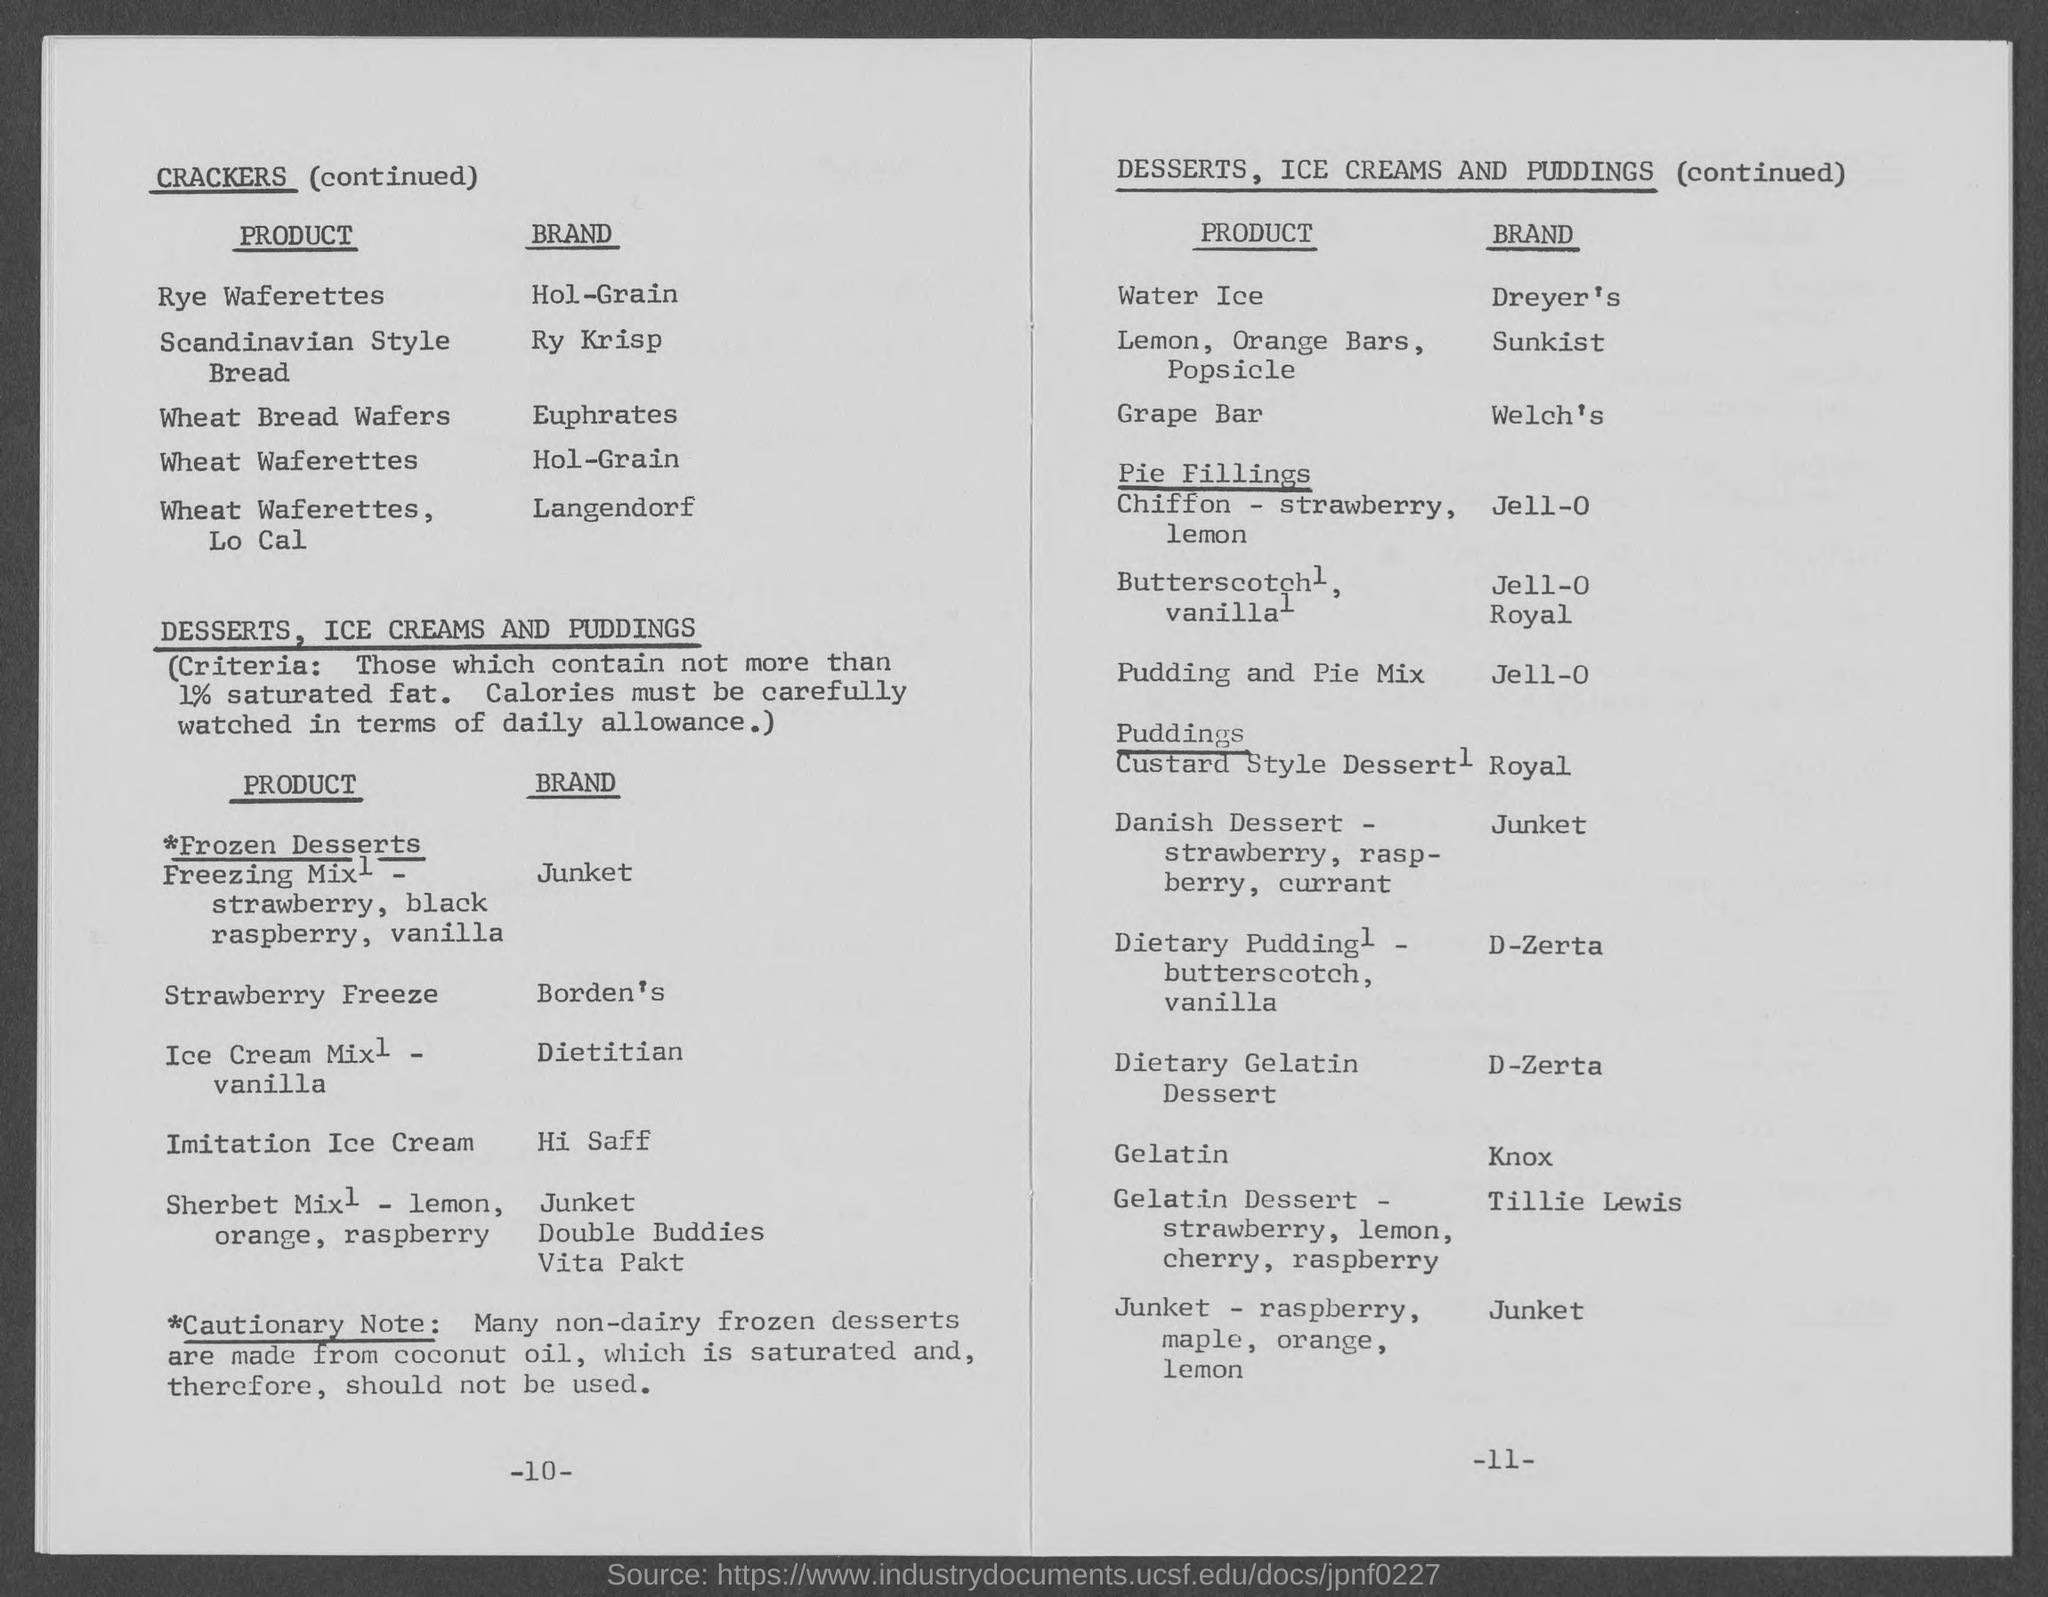Under the heading "crackers", which brand is given against Scandinavian Style Bread?
Your answer should be compact. Ry krisp. In the two column table given under the heading "crackers", what is the title of the first column?
Provide a short and direct response. Product. In the two column table given under the heading "crackers", what is the title of the second column?
Offer a very short reply. Brand. Which brand is given against Water Ice?
Keep it short and to the point. Dreyer's. Which product is associated with the "Welch's" brand?
Your answer should be very brief. Grape Bar. Which type of pudding is related to the brand "Knox"?
Your answer should be very brief. Gelatin. 